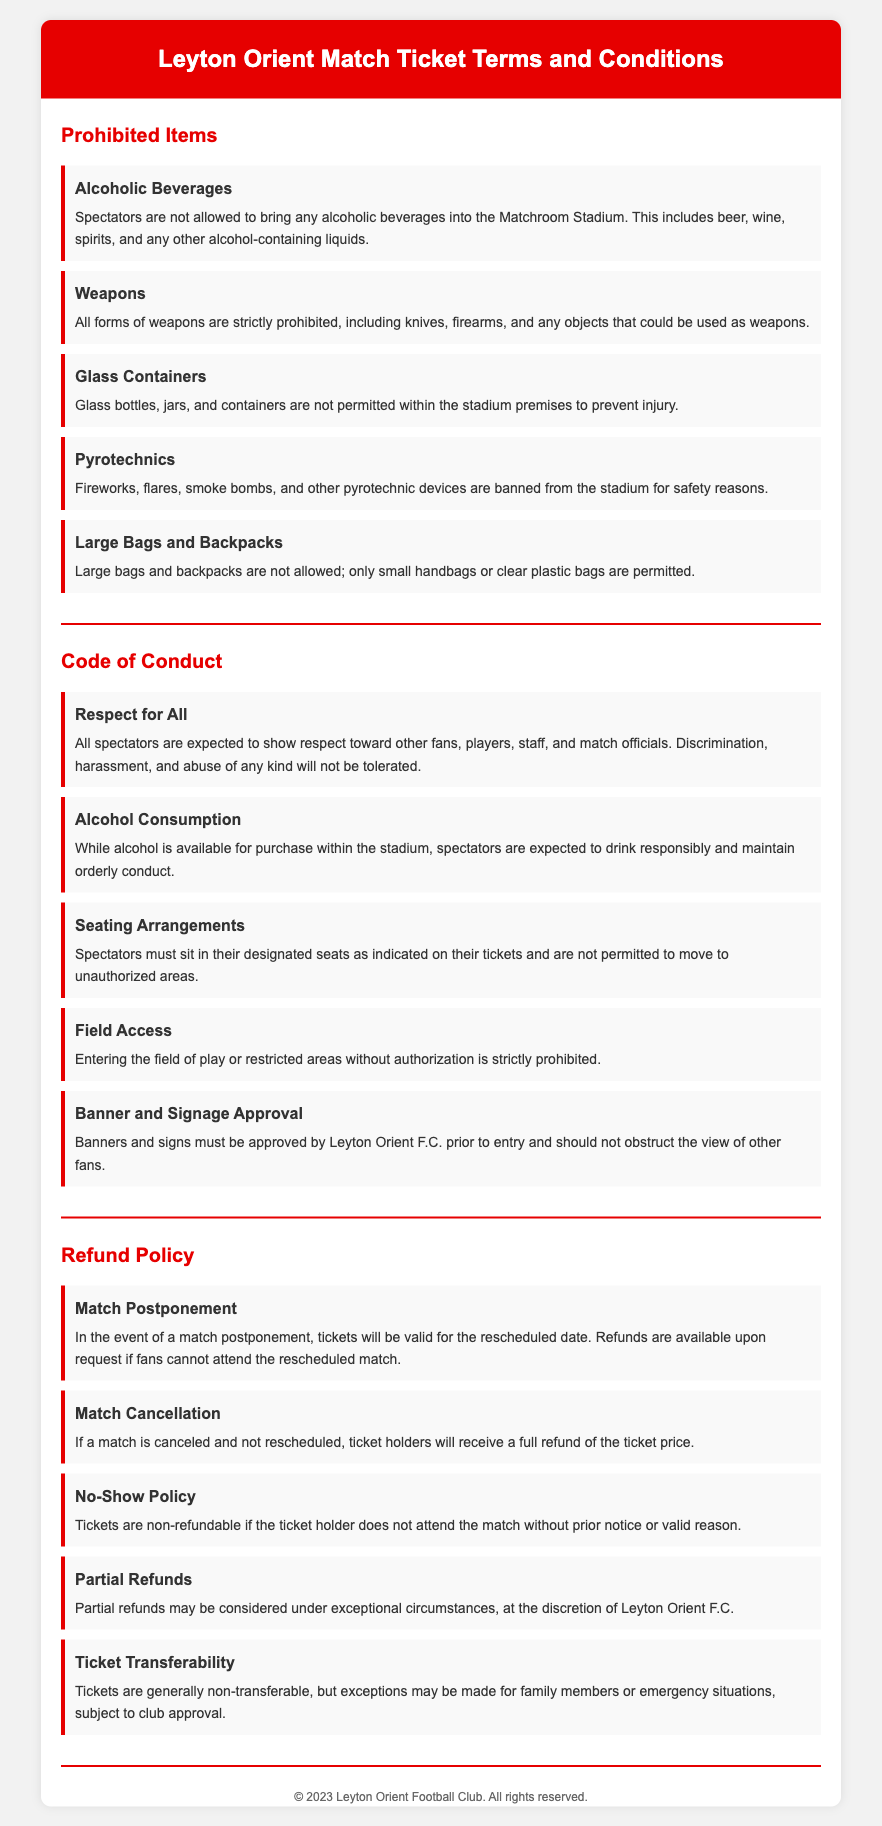What items are prohibited in the stadium? The document lists specific prohibited items within the "Prohibited Items" section, which includes alcoholic beverages, weapons, glass containers, pyrotechnics, and large bags and backpacks.
Answer: Alcoholic beverages, weapons, glass containers, pyrotechnics, large bags and backpacks What should spectators do regarding respect? Under the "Code of Conduct," it explicitly states that all spectators are expected to show respect toward other fans, players, staff, and match officials.
Answer: Show respect What is the refund policy if a match is canceled? The "Refund Policy" section mentions that if a match is canceled and not rescheduled, ticket holders will receive a full refund of the ticket price.
Answer: Full refund How are tickets handled in case of match postponement? The document explains that if a match is postponed, tickets will be valid for the rescheduled date and refunds are available upon request if fans cannot attend.
Answer: Valid for rescheduled date What is the requirement for banners and signs in the stadium? The "Code of Conduct" specifies that banners and signs must be approved by Leyton Orient F.C. prior to entry.
Answer: Approved by Leyton Orient F.C Are partial refunds available? The "Refund Policy" outlines that partial refunds may be considered under exceptional circumstances, at the discretion of Leyton Orient F.C.
Answer: Yes, under exceptional circumstances What type of containers are banned from the stadium? The document explicitly mentions that glass bottles, jars, and containers are not permitted within the stadium premises.
Answer: Glass containers What is the policy regarding ticket transferability? According to the "Refund Policy," tickets are generally non-transferable, but exceptions may be made for family members or emergency situations, subject to club approval.
Answer: Generally non-transferable 